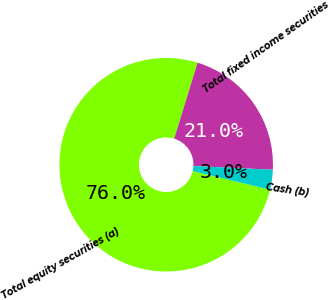<chart> <loc_0><loc_0><loc_500><loc_500><pie_chart><fcel>Total equity securities (a)<fcel>Total fixed income securities<fcel>Cash (b)<nl><fcel>76.0%<fcel>21.0%<fcel>3.0%<nl></chart> 